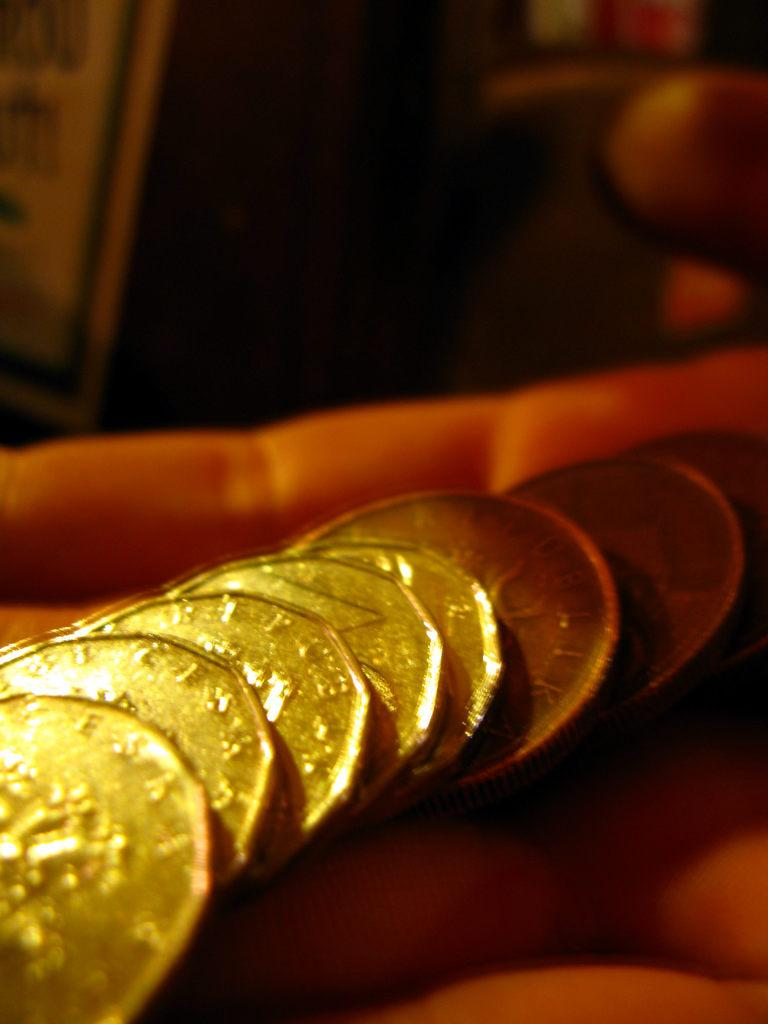What is on the hand of the person in the image? There are coins on the hand of a person in the image. Can you describe the background of the image? The background of the image is blurry. How many frogs are sitting on the bag in the image? There are no frogs or bags present in the image. 